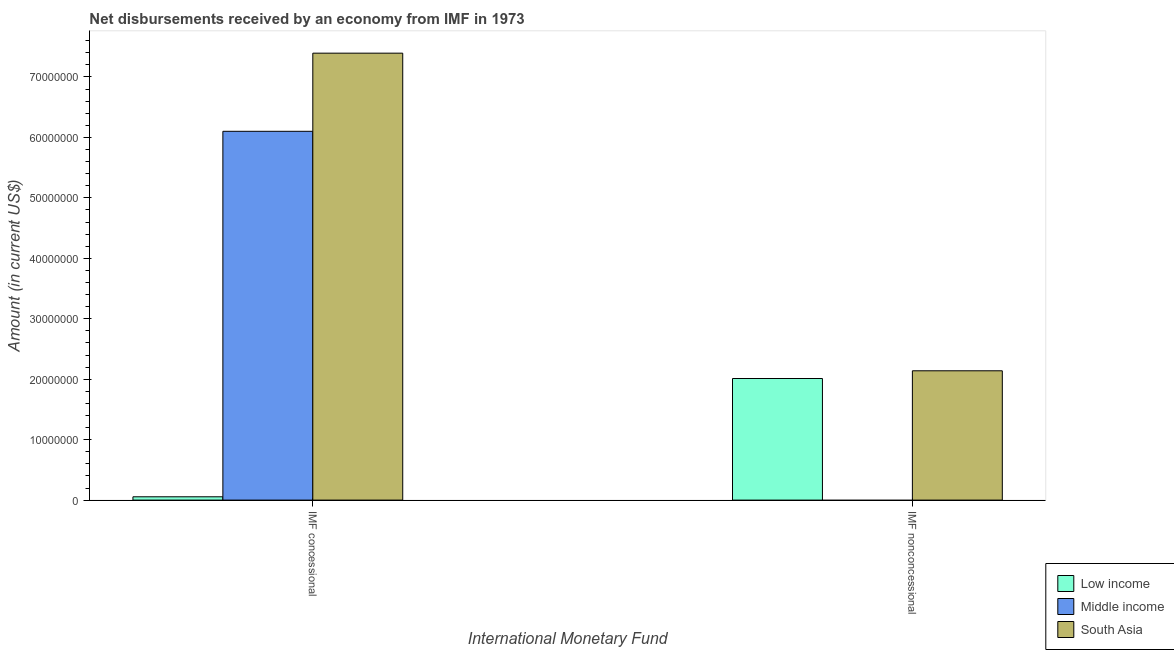How many groups of bars are there?
Your response must be concise. 2. Are the number of bars per tick equal to the number of legend labels?
Offer a terse response. No. Are the number of bars on each tick of the X-axis equal?
Ensure brevity in your answer.  No. How many bars are there on the 1st tick from the right?
Offer a terse response. 2. What is the label of the 1st group of bars from the left?
Offer a very short reply. IMF concessional. What is the net non concessional disbursements from imf in South Asia?
Your answer should be compact. 2.14e+07. Across all countries, what is the maximum net concessional disbursements from imf?
Offer a very short reply. 7.39e+07. Across all countries, what is the minimum net concessional disbursements from imf?
Ensure brevity in your answer.  5.46e+05. What is the total net non concessional disbursements from imf in the graph?
Give a very brief answer. 4.15e+07. What is the difference between the net concessional disbursements from imf in South Asia and that in Low income?
Provide a short and direct response. 7.34e+07. What is the difference between the net concessional disbursements from imf in South Asia and the net non concessional disbursements from imf in Low income?
Your response must be concise. 5.38e+07. What is the average net non concessional disbursements from imf per country?
Your answer should be very brief. 1.38e+07. What is the difference between the net non concessional disbursements from imf and net concessional disbursements from imf in South Asia?
Ensure brevity in your answer.  -5.25e+07. In how many countries, is the net concessional disbursements from imf greater than 70000000 US$?
Keep it short and to the point. 1. What is the ratio of the net concessional disbursements from imf in Low income to that in Middle income?
Your answer should be compact. 0.01. How many bars are there?
Offer a terse response. 5. Are all the bars in the graph horizontal?
Give a very brief answer. No. What is the difference between two consecutive major ticks on the Y-axis?
Ensure brevity in your answer.  1.00e+07. Does the graph contain any zero values?
Make the answer very short. Yes. Does the graph contain grids?
Keep it short and to the point. No. How are the legend labels stacked?
Offer a very short reply. Vertical. What is the title of the graph?
Your answer should be very brief. Net disbursements received by an economy from IMF in 1973. What is the label or title of the X-axis?
Offer a very short reply. International Monetary Fund. What is the Amount (in current US$) in Low income in IMF concessional?
Your response must be concise. 5.46e+05. What is the Amount (in current US$) of Middle income in IMF concessional?
Provide a succinct answer. 6.10e+07. What is the Amount (in current US$) of South Asia in IMF concessional?
Offer a terse response. 7.39e+07. What is the Amount (in current US$) in Low income in IMF nonconcessional?
Provide a succinct answer. 2.01e+07. What is the Amount (in current US$) in Middle income in IMF nonconcessional?
Keep it short and to the point. 0. What is the Amount (in current US$) in South Asia in IMF nonconcessional?
Provide a succinct answer. 2.14e+07. Across all International Monetary Fund, what is the maximum Amount (in current US$) in Low income?
Offer a very short reply. 2.01e+07. Across all International Monetary Fund, what is the maximum Amount (in current US$) of Middle income?
Your answer should be compact. 6.10e+07. Across all International Monetary Fund, what is the maximum Amount (in current US$) of South Asia?
Offer a very short reply. 7.39e+07. Across all International Monetary Fund, what is the minimum Amount (in current US$) of Low income?
Your answer should be very brief. 5.46e+05. Across all International Monetary Fund, what is the minimum Amount (in current US$) in Middle income?
Provide a short and direct response. 0. Across all International Monetary Fund, what is the minimum Amount (in current US$) in South Asia?
Offer a terse response. 2.14e+07. What is the total Amount (in current US$) in Low income in the graph?
Offer a terse response. 2.07e+07. What is the total Amount (in current US$) of Middle income in the graph?
Provide a short and direct response. 6.10e+07. What is the total Amount (in current US$) in South Asia in the graph?
Offer a terse response. 9.53e+07. What is the difference between the Amount (in current US$) in Low income in IMF concessional and that in IMF nonconcessional?
Offer a terse response. -1.96e+07. What is the difference between the Amount (in current US$) in South Asia in IMF concessional and that in IMF nonconcessional?
Offer a terse response. 5.25e+07. What is the difference between the Amount (in current US$) of Low income in IMF concessional and the Amount (in current US$) of South Asia in IMF nonconcessional?
Keep it short and to the point. -2.08e+07. What is the difference between the Amount (in current US$) of Middle income in IMF concessional and the Amount (in current US$) of South Asia in IMF nonconcessional?
Offer a very short reply. 3.96e+07. What is the average Amount (in current US$) in Low income per International Monetary Fund?
Make the answer very short. 1.03e+07. What is the average Amount (in current US$) of Middle income per International Monetary Fund?
Your answer should be compact. 3.05e+07. What is the average Amount (in current US$) in South Asia per International Monetary Fund?
Offer a terse response. 4.77e+07. What is the difference between the Amount (in current US$) of Low income and Amount (in current US$) of Middle income in IMF concessional?
Make the answer very short. -6.05e+07. What is the difference between the Amount (in current US$) of Low income and Amount (in current US$) of South Asia in IMF concessional?
Make the answer very short. -7.34e+07. What is the difference between the Amount (in current US$) of Middle income and Amount (in current US$) of South Asia in IMF concessional?
Provide a short and direct response. -1.29e+07. What is the difference between the Amount (in current US$) of Low income and Amount (in current US$) of South Asia in IMF nonconcessional?
Provide a short and direct response. -1.28e+06. What is the ratio of the Amount (in current US$) of Low income in IMF concessional to that in IMF nonconcessional?
Give a very brief answer. 0.03. What is the ratio of the Amount (in current US$) in South Asia in IMF concessional to that in IMF nonconcessional?
Offer a terse response. 3.46. What is the difference between the highest and the second highest Amount (in current US$) of Low income?
Keep it short and to the point. 1.96e+07. What is the difference between the highest and the second highest Amount (in current US$) of South Asia?
Your response must be concise. 5.25e+07. What is the difference between the highest and the lowest Amount (in current US$) of Low income?
Provide a succinct answer. 1.96e+07. What is the difference between the highest and the lowest Amount (in current US$) of Middle income?
Your answer should be very brief. 6.10e+07. What is the difference between the highest and the lowest Amount (in current US$) in South Asia?
Provide a succinct answer. 5.25e+07. 